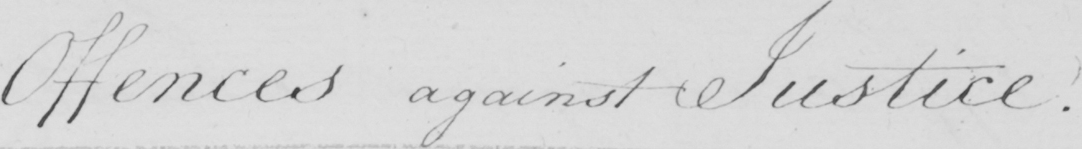Please transcribe the handwritten text in this image. Offences against Justice . 